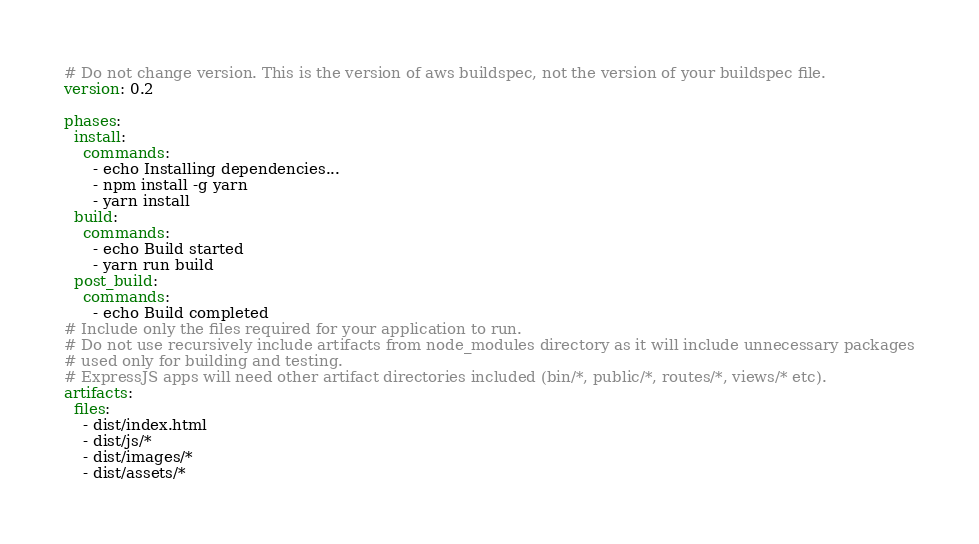<code> <loc_0><loc_0><loc_500><loc_500><_YAML_># Do not change version. This is the version of aws buildspec, not the version of your buildspec file.
version: 0.2

phases:
  install:
    commands:
      - echo Installing dependencies...
      - npm install -g yarn
      - yarn install
  build:
    commands:
      - echo Build started
      - yarn run build
  post_build:
    commands:
      - echo Build completed
# Include only the files required for your application to run.
# Do not use recursively include artifacts from node_modules directory as it will include unnecessary packages
# used only for building and testing.
# ExpressJS apps will need other artifact directories included (bin/*, public/*, routes/*, views/* etc).
artifacts:
  files:
    - dist/index.html
    - dist/js/*
    - dist/images/*
    - dist/assets/*
</code> 